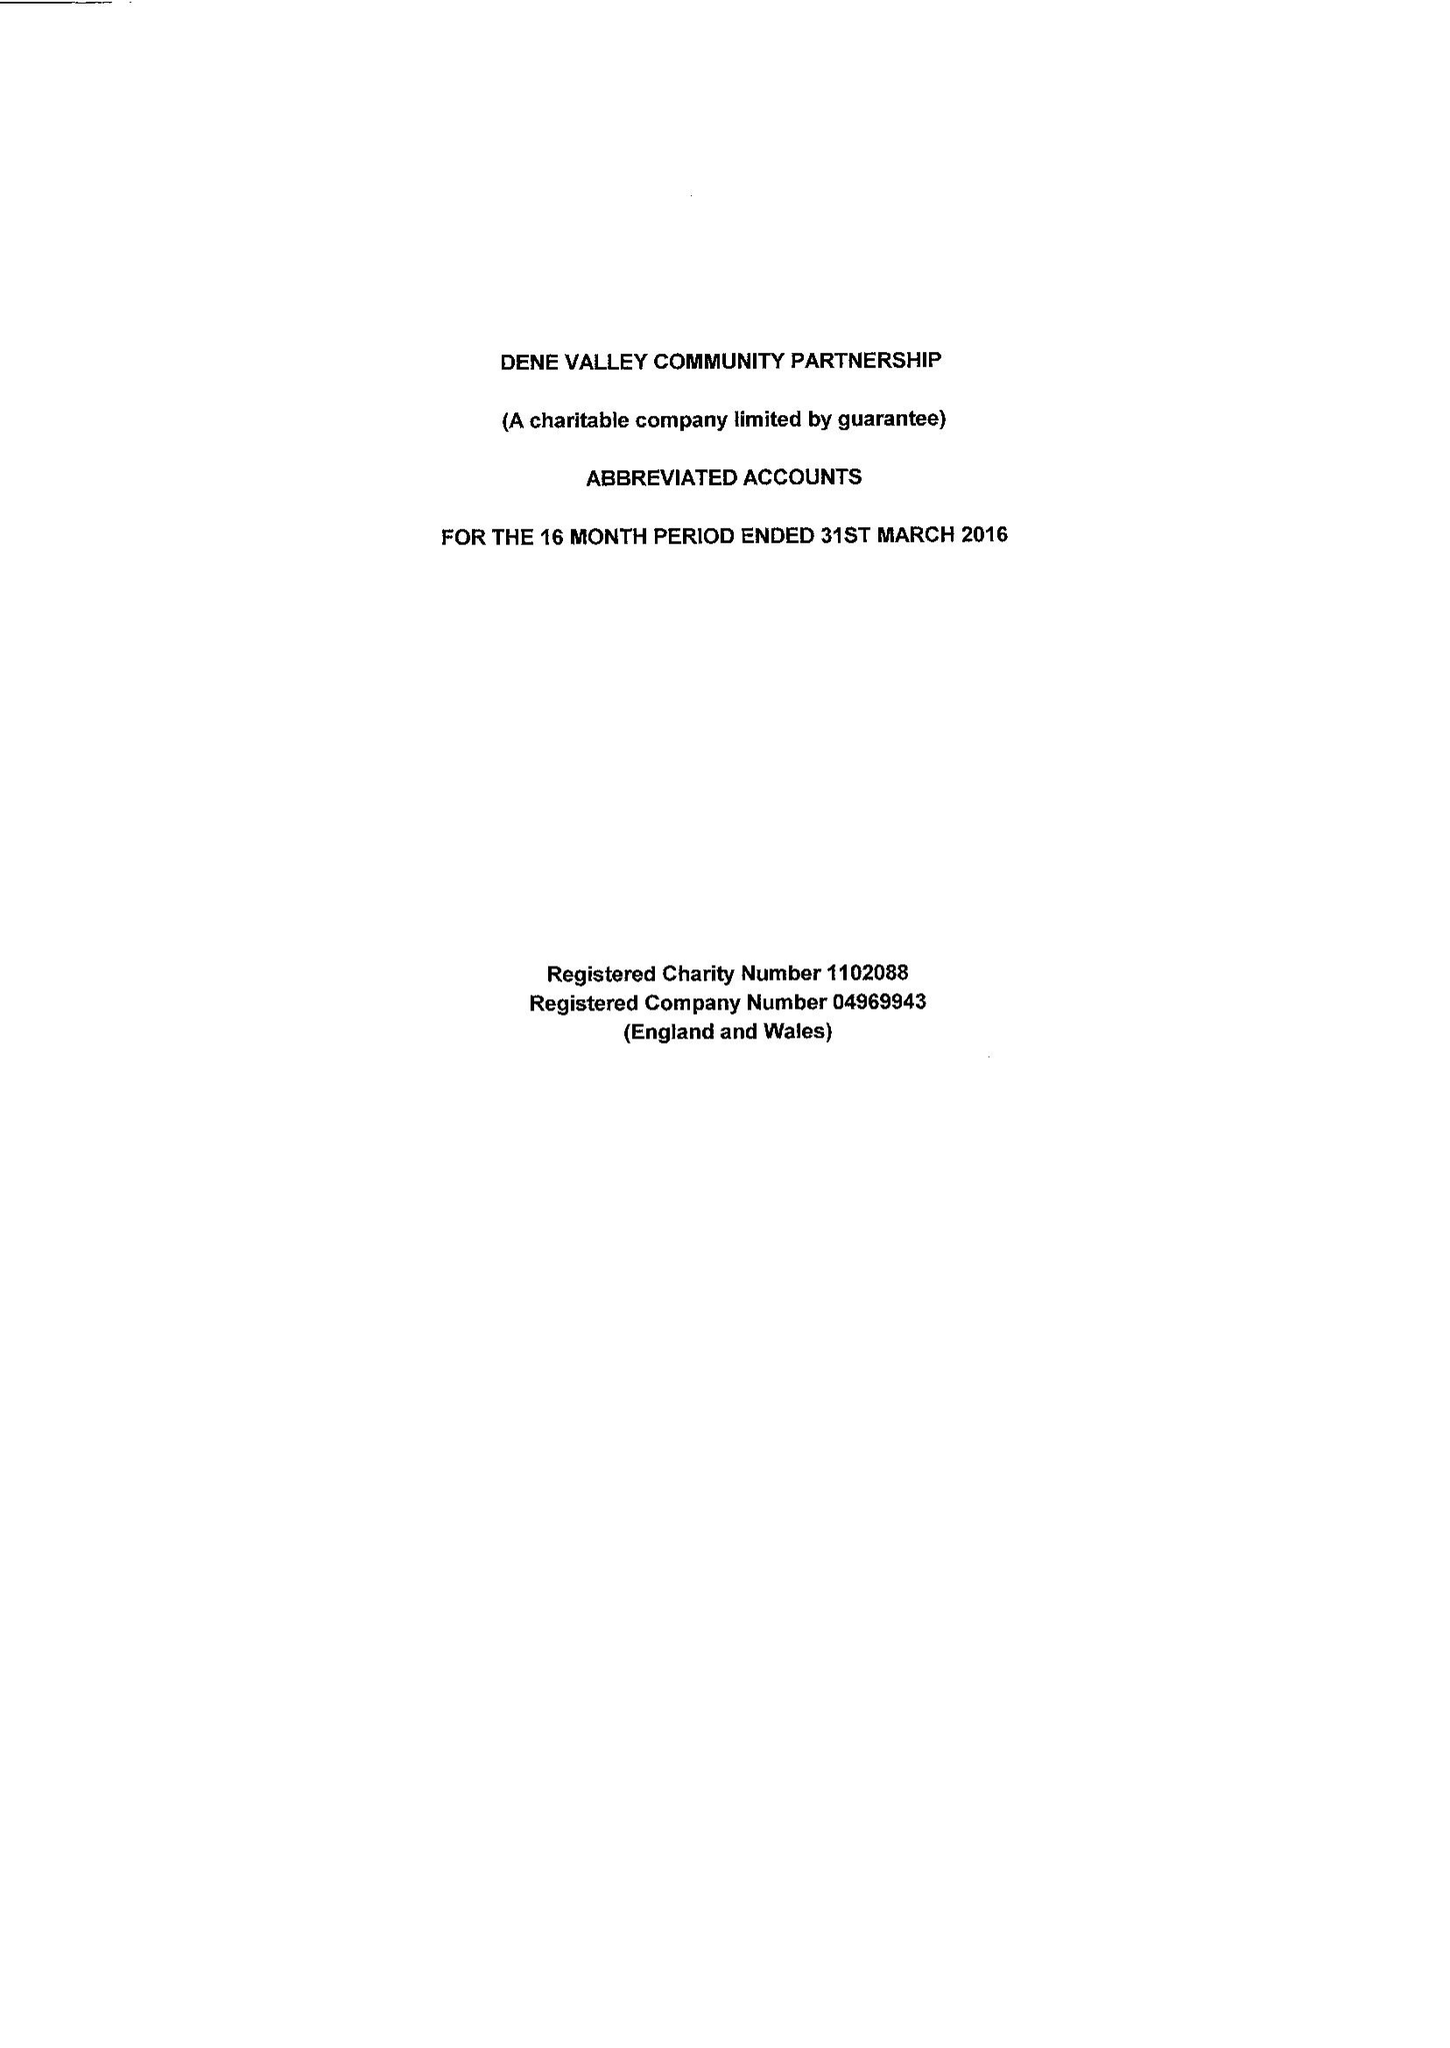What is the value for the charity_name?
Answer the question using a single word or phrase. Dene Valley Community Partnership Ltd. 